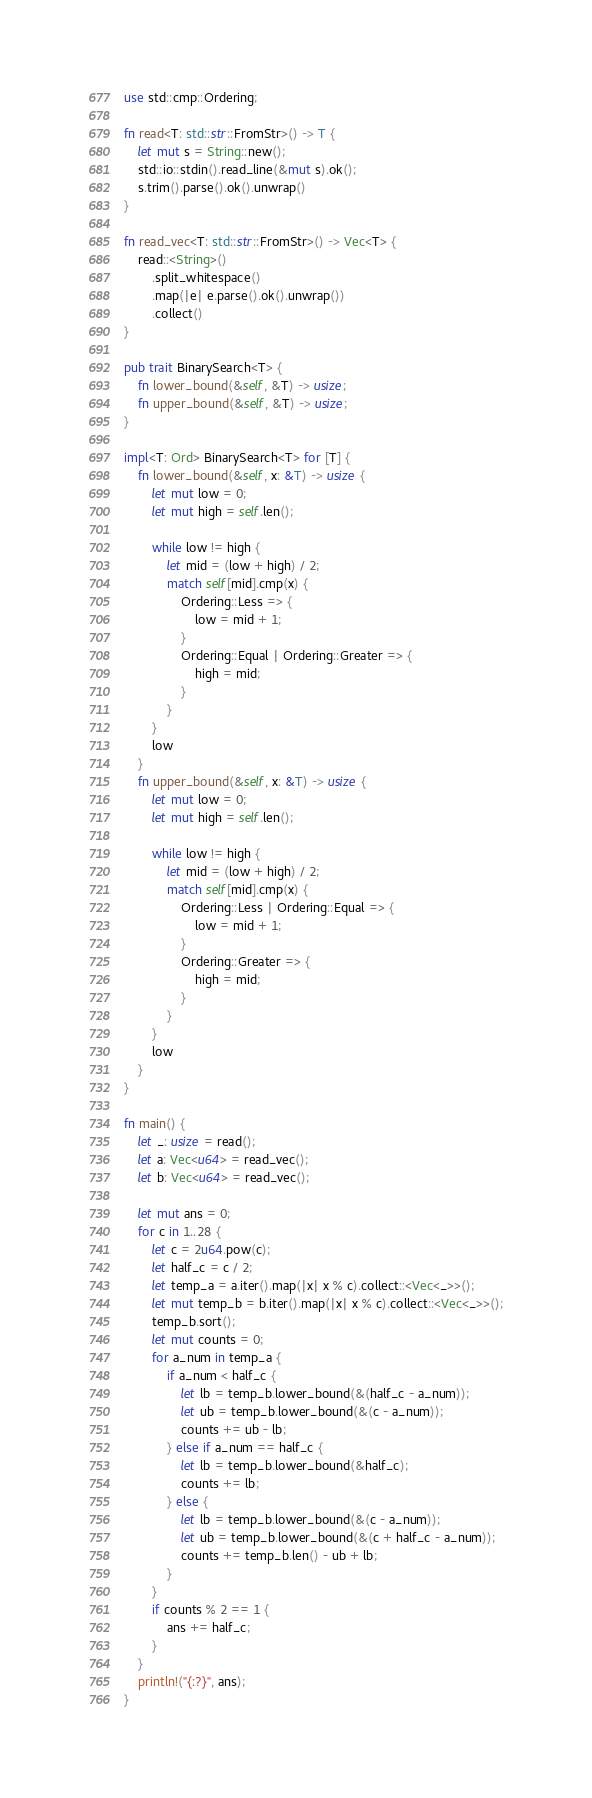Convert code to text. <code><loc_0><loc_0><loc_500><loc_500><_Rust_>use std::cmp::Ordering;

fn read<T: std::str::FromStr>() -> T {
    let mut s = String::new();
    std::io::stdin().read_line(&mut s).ok();
    s.trim().parse().ok().unwrap()
}

fn read_vec<T: std::str::FromStr>() -> Vec<T> {
    read::<String>()
        .split_whitespace()
        .map(|e| e.parse().ok().unwrap())
        .collect()
}

pub trait BinarySearch<T> {
    fn lower_bound(&self, &T) -> usize;
    fn upper_bound(&self, &T) -> usize;
}

impl<T: Ord> BinarySearch<T> for [T] {
    fn lower_bound(&self, x: &T) -> usize {
        let mut low = 0;
        let mut high = self.len();

        while low != high {
            let mid = (low + high) / 2;
            match self[mid].cmp(x) {
                Ordering::Less => {
                    low = mid + 1;
                }
                Ordering::Equal | Ordering::Greater => {
                    high = mid;
                }
            }
        }
        low
    }
    fn upper_bound(&self, x: &T) -> usize {
        let mut low = 0;
        let mut high = self.len();

        while low != high {
            let mid = (low + high) / 2;
            match self[mid].cmp(x) {
                Ordering::Less | Ordering::Equal => {
                    low = mid + 1;
                }
                Ordering::Greater => {
                    high = mid;
                }
            }
        }
        low
    }
}

fn main() {
    let _: usize = read();
    let a: Vec<u64> = read_vec();
    let b: Vec<u64> = read_vec();

    let mut ans = 0;
    for c in 1..28 {
        let c = 2u64.pow(c);
        let half_c = c / 2;
        let temp_a = a.iter().map(|x| x % c).collect::<Vec<_>>();
        let mut temp_b = b.iter().map(|x| x % c).collect::<Vec<_>>();
        temp_b.sort();
        let mut counts = 0;
        for a_num in temp_a {
            if a_num < half_c {
                let lb = temp_b.lower_bound(&(half_c - a_num));
                let ub = temp_b.lower_bound(&(c - a_num));
                counts += ub - lb;
            } else if a_num == half_c {
                let lb = temp_b.lower_bound(&half_c);
                counts += lb;
            } else {
                let lb = temp_b.lower_bound(&(c - a_num));
                let ub = temp_b.lower_bound(&(c + half_c - a_num));
                counts += temp_b.len() - ub + lb;
            }
        }
        if counts % 2 == 1 {
            ans += half_c;
        }
    }
    println!("{:?}", ans);
}
</code> 